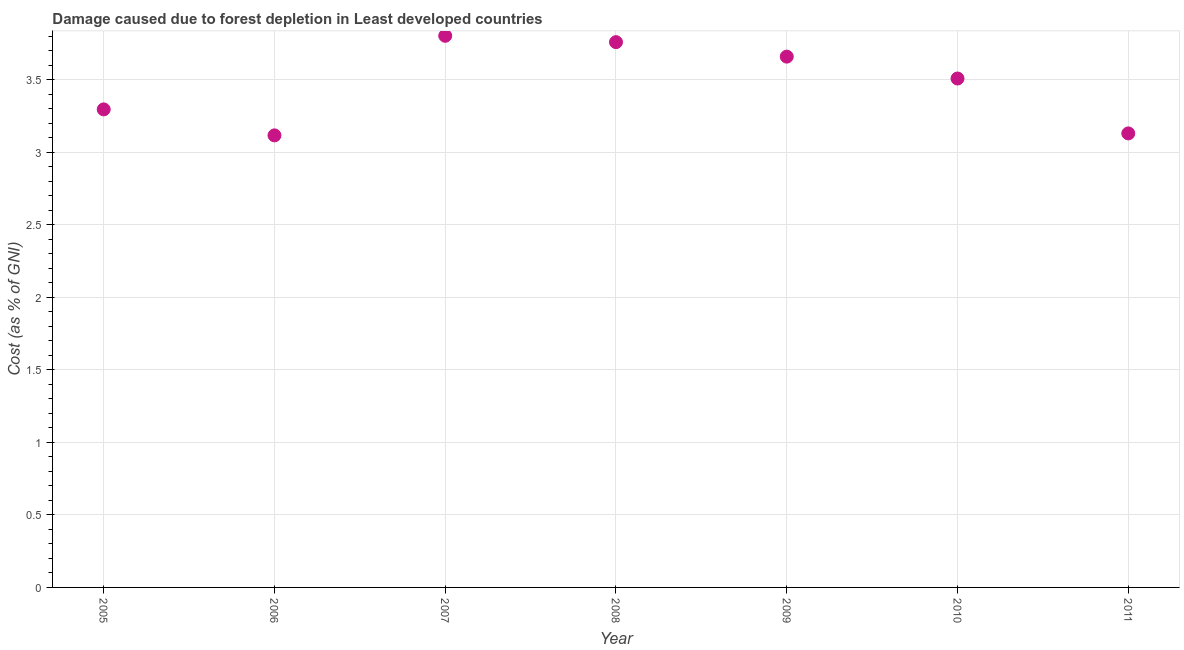What is the damage caused due to forest depletion in 2008?
Offer a very short reply. 3.76. Across all years, what is the maximum damage caused due to forest depletion?
Offer a very short reply. 3.8. Across all years, what is the minimum damage caused due to forest depletion?
Offer a very short reply. 3.12. In which year was the damage caused due to forest depletion minimum?
Give a very brief answer. 2006. What is the sum of the damage caused due to forest depletion?
Provide a succinct answer. 24.26. What is the difference between the damage caused due to forest depletion in 2010 and 2011?
Your answer should be very brief. 0.38. What is the average damage caused due to forest depletion per year?
Provide a succinct answer. 3.47. What is the median damage caused due to forest depletion?
Keep it short and to the point. 3.51. Do a majority of the years between 2006 and 2010 (inclusive) have damage caused due to forest depletion greater than 1.7 %?
Provide a succinct answer. Yes. What is the ratio of the damage caused due to forest depletion in 2005 to that in 2009?
Your answer should be very brief. 0.9. Is the damage caused due to forest depletion in 2008 less than that in 2011?
Offer a very short reply. No. Is the difference between the damage caused due to forest depletion in 2007 and 2009 greater than the difference between any two years?
Make the answer very short. No. What is the difference between the highest and the second highest damage caused due to forest depletion?
Your answer should be compact. 0.04. What is the difference between the highest and the lowest damage caused due to forest depletion?
Your response must be concise. 0.69. In how many years, is the damage caused due to forest depletion greater than the average damage caused due to forest depletion taken over all years?
Your response must be concise. 4. Does the damage caused due to forest depletion monotonically increase over the years?
Provide a short and direct response. No. How many dotlines are there?
Make the answer very short. 1. What is the title of the graph?
Provide a succinct answer. Damage caused due to forest depletion in Least developed countries. What is the label or title of the X-axis?
Make the answer very short. Year. What is the label or title of the Y-axis?
Offer a very short reply. Cost (as % of GNI). What is the Cost (as % of GNI) in 2005?
Keep it short and to the point. 3.29. What is the Cost (as % of GNI) in 2006?
Provide a short and direct response. 3.12. What is the Cost (as % of GNI) in 2007?
Offer a very short reply. 3.8. What is the Cost (as % of GNI) in 2008?
Offer a very short reply. 3.76. What is the Cost (as % of GNI) in 2009?
Offer a very short reply. 3.66. What is the Cost (as % of GNI) in 2010?
Provide a short and direct response. 3.51. What is the Cost (as % of GNI) in 2011?
Provide a succinct answer. 3.13. What is the difference between the Cost (as % of GNI) in 2005 and 2006?
Offer a terse response. 0.18. What is the difference between the Cost (as % of GNI) in 2005 and 2007?
Give a very brief answer. -0.51. What is the difference between the Cost (as % of GNI) in 2005 and 2008?
Give a very brief answer. -0.46. What is the difference between the Cost (as % of GNI) in 2005 and 2009?
Provide a short and direct response. -0.36. What is the difference between the Cost (as % of GNI) in 2005 and 2010?
Keep it short and to the point. -0.21. What is the difference between the Cost (as % of GNI) in 2005 and 2011?
Your response must be concise. 0.17. What is the difference between the Cost (as % of GNI) in 2006 and 2007?
Provide a succinct answer. -0.69. What is the difference between the Cost (as % of GNI) in 2006 and 2008?
Provide a short and direct response. -0.64. What is the difference between the Cost (as % of GNI) in 2006 and 2009?
Offer a terse response. -0.54. What is the difference between the Cost (as % of GNI) in 2006 and 2010?
Offer a very short reply. -0.39. What is the difference between the Cost (as % of GNI) in 2006 and 2011?
Make the answer very short. -0.01. What is the difference between the Cost (as % of GNI) in 2007 and 2008?
Offer a terse response. 0.04. What is the difference between the Cost (as % of GNI) in 2007 and 2009?
Give a very brief answer. 0.14. What is the difference between the Cost (as % of GNI) in 2007 and 2010?
Keep it short and to the point. 0.29. What is the difference between the Cost (as % of GNI) in 2007 and 2011?
Your answer should be compact. 0.67. What is the difference between the Cost (as % of GNI) in 2008 and 2009?
Offer a terse response. 0.1. What is the difference between the Cost (as % of GNI) in 2008 and 2010?
Offer a terse response. 0.25. What is the difference between the Cost (as % of GNI) in 2008 and 2011?
Your response must be concise. 0.63. What is the difference between the Cost (as % of GNI) in 2009 and 2010?
Your answer should be compact. 0.15. What is the difference between the Cost (as % of GNI) in 2009 and 2011?
Offer a terse response. 0.53. What is the difference between the Cost (as % of GNI) in 2010 and 2011?
Provide a short and direct response. 0.38. What is the ratio of the Cost (as % of GNI) in 2005 to that in 2006?
Offer a terse response. 1.06. What is the ratio of the Cost (as % of GNI) in 2005 to that in 2007?
Offer a very short reply. 0.87. What is the ratio of the Cost (as % of GNI) in 2005 to that in 2008?
Make the answer very short. 0.88. What is the ratio of the Cost (as % of GNI) in 2005 to that in 2009?
Ensure brevity in your answer.  0.9. What is the ratio of the Cost (as % of GNI) in 2005 to that in 2010?
Offer a very short reply. 0.94. What is the ratio of the Cost (as % of GNI) in 2005 to that in 2011?
Offer a very short reply. 1.05. What is the ratio of the Cost (as % of GNI) in 2006 to that in 2007?
Provide a short and direct response. 0.82. What is the ratio of the Cost (as % of GNI) in 2006 to that in 2008?
Provide a short and direct response. 0.83. What is the ratio of the Cost (as % of GNI) in 2006 to that in 2009?
Give a very brief answer. 0.85. What is the ratio of the Cost (as % of GNI) in 2006 to that in 2010?
Provide a succinct answer. 0.89. What is the ratio of the Cost (as % of GNI) in 2007 to that in 2008?
Your response must be concise. 1.01. What is the ratio of the Cost (as % of GNI) in 2007 to that in 2009?
Keep it short and to the point. 1.04. What is the ratio of the Cost (as % of GNI) in 2007 to that in 2010?
Your response must be concise. 1.08. What is the ratio of the Cost (as % of GNI) in 2007 to that in 2011?
Keep it short and to the point. 1.22. What is the ratio of the Cost (as % of GNI) in 2008 to that in 2010?
Provide a short and direct response. 1.07. What is the ratio of the Cost (as % of GNI) in 2008 to that in 2011?
Make the answer very short. 1.2. What is the ratio of the Cost (as % of GNI) in 2009 to that in 2010?
Provide a succinct answer. 1.04. What is the ratio of the Cost (as % of GNI) in 2009 to that in 2011?
Give a very brief answer. 1.17. What is the ratio of the Cost (as % of GNI) in 2010 to that in 2011?
Offer a very short reply. 1.12. 